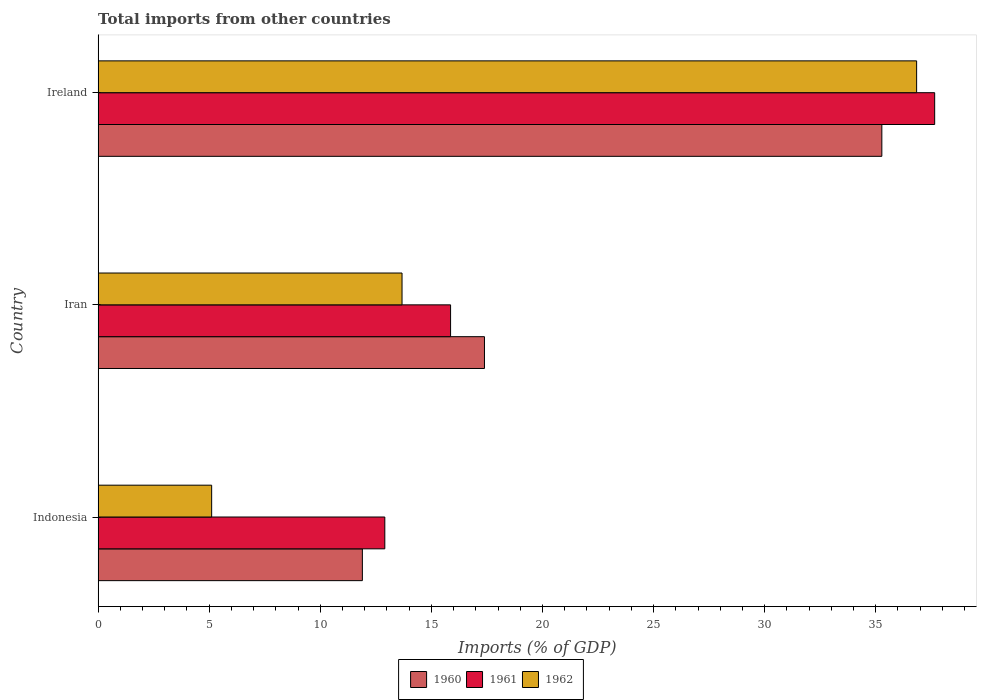How many different coloured bars are there?
Give a very brief answer. 3. Are the number of bars per tick equal to the number of legend labels?
Ensure brevity in your answer.  Yes. Are the number of bars on each tick of the Y-axis equal?
Give a very brief answer. Yes. How many bars are there on the 1st tick from the bottom?
Your response must be concise. 3. What is the label of the 2nd group of bars from the top?
Your answer should be very brief. Iran. In how many cases, is the number of bars for a given country not equal to the number of legend labels?
Give a very brief answer. 0. What is the total imports in 1962 in Ireland?
Your answer should be very brief. 36.84. Across all countries, what is the maximum total imports in 1960?
Offer a terse response. 35.27. Across all countries, what is the minimum total imports in 1961?
Your answer should be compact. 12.9. In which country was the total imports in 1962 maximum?
Keep it short and to the point. Ireland. In which country was the total imports in 1960 minimum?
Make the answer very short. Indonesia. What is the total total imports in 1960 in the graph?
Your answer should be very brief. 64.56. What is the difference between the total imports in 1960 in Iran and that in Ireland?
Your answer should be very brief. -17.88. What is the difference between the total imports in 1962 in Ireland and the total imports in 1960 in Iran?
Offer a terse response. 19.45. What is the average total imports in 1961 per country?
Your response must be concise. 22.14. What is the difference between the total imports in 1960 and total imports in 1962 in Indonesia?
Provide a succinct answer. 6.78. In how many countries, is the total imports in 1961 greater than 29 %?
Ensure brevity in your answer.  1. What is the ratio of the total imports in 1960 in Iran to that in Ireland?
Provide a short and direct response. 0.49. Is the total imports in 1962 in Indonesia less than that in Ireland?
Give a very brief answer. Yes. What is the difference between the highest and the second highest total imports in 1962?
Provide a short and direct response. 23.16. What is the difference between the highest and the lowest total imports in 1961?
Provide a short and direct response. 24.75. In how many countries, is the total imports in 1961 greater than the average total imports in 1961 taken over all countries?
Offer a very short reply. 1. Is it the case that in every country, the sum of the total imports in 1960 and total imports in 1962 is greater than the total imports in 1961?
Give a very brief answer. Yes. How many bars are there?
Provide a succinct answer. 9. How many countries are there in the graph?
Provide a short and direct response. 3. Does the graph contain any zero values?
Provide a succinct answer. No. Does the graph contain grids?
Your response must be concise. No. Where does the legend appear in the graph?
Keep it short and to the point. Bottom center. How are the legend labels stacked?
Make the answer very short. Horizontal. What is the title of the graph?
Your answer should be compact. Total imports from other countries. What is the label or title of the X-axis?
Give a very brief answer. Imports (% of GDP). What is the label or title of the Y-axis?
Offer a very short reply. Country. What is the Imports (% of GDP) in 1960 in Indonesia?
Your answer should be very brief. 11.89. What is the Imports (% of GDP) in 1961 in Indonesia?
Ensure brevity in your answer.  12.9. What is the Imports (% of GDP) of 1962 in Indonesia?
Your response must be concise. 5.11. What is the Imports (% of GDP) in 1960 in Iran?
Ensure brevity in your answer.  17.39. What is the Imports (% of GDP) in 1961 in Iran?
Offer a very short reply. 15.86. What is the Imports (% of GDP) of 1962 in Iran?
Offer a terse response. 13.68. What is the Imports (% of GDP) in 1960 in Ireland?
Make the answer very short. 35.27. What is the Imports (% of GDP) of 1961 in Ireland?
Ensure brevity in your answer.  37.65. What is the Imports (% of GDP) in 1962 in Ireland?
Give a very brief answer. 36.84. Across all countries, what is the maximum Imports (% of GDP) in 1960?
Give a very brief answer. 35.27. Across all countries, what is the maximum Imports (% of GDP) in 1961?
Your response must be concise. 37.65. Across all countries, what is the maximum Imports (% of GDP) in 1962?
Your response must be concise. 36.84. Across all countries, what is the minimum Imports (% of GDP) of 1960?
Offer a terse response. 11.89. Across all countries, what is the minimum Imports (% of GDP) of 1961?
Offer a terse response. 12.9. Across all countries, what is the minimum Imports (% of GDP) of 1962?
Provide a succinct answer. 5.11. What is the total Imports (% of GDP) in 1960 in the graph?
Offer a very short reply. 64.56. What is the total Imports (% of GDP) in 1961 in the graph?
Give a very brief answer. 66.42. What is the total Imports (% of GDP) in 1962 in the graph?
Give a very brief answer. 55.63. What is the difference between the Imports (% of GDP) of 1960 in Indonesia and that in Iran?
Your response must be concise. -5.5. What is the difference between the Imports (% of GDP) of 1961 in Indonesia and that in Iran?
Offer a very short reply. -2.96. What is the difference between the Imports (% of GDP) of 1962 in Indonesia and that in Iran?
Keep it short and to the point. -8.57. What is the difference between the Imports (% of GDP) of 1960 in Indonesia and that in Ireland?
Your answer should be compact. -23.38. What is the difference between the Imports (% of GDP) in 1961 in Indonesia and that in Ireland?
Make the answer very short. -24.75. What is the difference between the Imports (% of GDP) of 1962 in Indonesia and that in Ireland?
Ensure brevity in your answer.  -31.73. What is the difference between the Imports (% of GDP) of 1960 in Iran and that in Ireland?
Your response must be concise. -17.88. What is the difference between the Imports (% of GDP) of 1961 in Iran and that in Ireland?
Your answer should be very brief. -21.79. What is the difference between the Imports (% of GDP) of 1962 in Iran and that in Ireland?
Provide a short and direct response. -23.16. What is the difference between the Imports (% of GDP) in 1960 in Indonesia and the Imports (% of GDP) in 1961 in Iran?
Provide a short and direct response. -3.97. What is the difference between the Imports (% of GDP) of 1960 in Indonesia and the Imports (% of GDP) of 1962 in Iran?
Provide a succinct answer. -1.79. What is the difference between the Imports (% of GDP) in 1961 in Indonesia and the Imports (% of GDP) in 1962 in Iran?
Your answer should be very brief. -0.78. What is the difference between the Imports (% of GDP) in 1960 in Indonesia and the Imports (% of GDP) in 1961 in Ireland?
Offer a very short reply. -25.76. What is the difference between the Imports (% of GDP) in 1960 in Indonesia and the Imports (% of GDP) in 1962 in Ireland?
Provide a short and direct response. -24.95. What is the difference between the Imports (% of GDP) in 1961 in Indonesia and the Imports (% of GDP) in 1962 in Ireland?
Offer a very short reply. -23.94. What is the difference between the Imports (% of GDP) of 1960 in Iran and the Imports (% of GDP) of 1961 in Ireland?
Offer a terse response. -20.26. What is the difference between the Imports (% of GDP) in 1960 in Iran and the Imports (% of GDP) in 1962 in Ireland?
Offer a very short reply. -19.45. What is the difference between the Imports (% of GDP) of 1961 in Iran and the Imports (% of GDP) of 1962 in Ireland?
Provide a succinct answer. -20.98. What is the average Imports (% of GDP) of 1960 per country?
Ensure brevity in your answer.  21.52. What is the average Imports (% of GDP) in 1961 per country?
Give a very brief answer. 22.14. What is the average Imports (% of GDP) of 1962 per country?
Make the answer very short. 18.54. What is the difference between the Imports (% of GDP) of 1960 and Imports (% of GDP) of 1961 in Indonesia?
Offer a terse response. -1.01. What is the difference between the Imports (% of GDP) in 1960 and Imports (% of GDP) in 1962 in Indonesia?
Ensure brevity in your answer.  6.78. What is the difference between the Imports (% of GDP) of 1961 and Imports (% of GDP) of 1962 in Indonesia?
Offer a terse response. 7.79. What is the difference between the Imports (% of GDP) in 1960 and Imports (% of GDP) in 1961 in Iran?
Provide a short and direct response. 1.53. What is the difference between the Imports (% of GDP) of 1960 and Imports (% of GDP) of 1962 in Iran?
Your answer should be very brief. 3.71. What is the difference between the Imports (% of GDP) of 1961 and Imports (% of GDP) of 1962 in Iran?
Ensure brevity in your answer.  2.18. What is the difference between the Imports (% of GDP) in 1960 and Imports (% of GDP) in 1961 in Ireland?
Keep it short and to the point. -2.38. What is the difference between the Imports (% of GDP) of 1960 and Imports (% of GDP) of 1962 in Ireland?
Your response must be concise. -1.57. What is the difference between the Imports (% of GDP) in 1961 and Imports (% of GDP) in 1962 in Ireland?
Keep it short and to the point. 0.81. What is the ratio of the Imports (% of GDP) of 1960 in Indonesia to that in Iran?
Ensure brevity in your answer.  0.68. What is the ratio of the Imports (% of GDP) in 1961 in Indonesia to that in Iran?
Provide a succinct answer. 0.81. What is the ratio of the Imports (% of GDP) in 1962 in Indonesia to that in Iran?
Your answer should be compact. 0.37. What is the ratio of the Imports (% of GDP) of 1960 in Indonesia to that in Ireland?
Your response must be concise. 0.34. What is the ratio of the Imports (% of GDP) in 1961 in Indonesia to that in Ireland?
Ensure brevity in your answer.  0.34. What is the ratio of the Imports (% of GDP) in 1962 in Indonesia to that in Ireland?
Offer a very short reply. 0.14. What is the ratio of the Imports (% of GDP) in 1960 in Iran to that in Ireland?
Provide a short and direct response. 0.49. What is the ratio of the Imports (% of GDP) of 1961 in Iran to that in Ireland?
Offer a very short reply. 0.42. What is the ratio of the Imports (% of GDP) in 1962 in Iran to that in Ireland?
Your response must be concise. 0.37. What is the difference between the highest and the second highest Imports (% of GDP) in 1960?
Provide a short and direct response. 17.88. What is the difference between the highest and the second highest Imports (% of GDP) of 1961?
Offer a very short reply. 21.79. What is the difference between the highest and the second highest Imports (% of GDP) of 1962?
Ensure brevity in your answer.  23.16. What is the difference between the highest and the lowest Imports (% of GDP) in 1960?
Your answer should be very brief. 23.38. What is the difference between the highest and the lowest Imports (% of GDP) in 1961?
Give a very brief answer. 24.75. What is the difference between the highest and the lowest Imports (% of GDP) of 1962?
Your answer should be very brief. 31.73. 